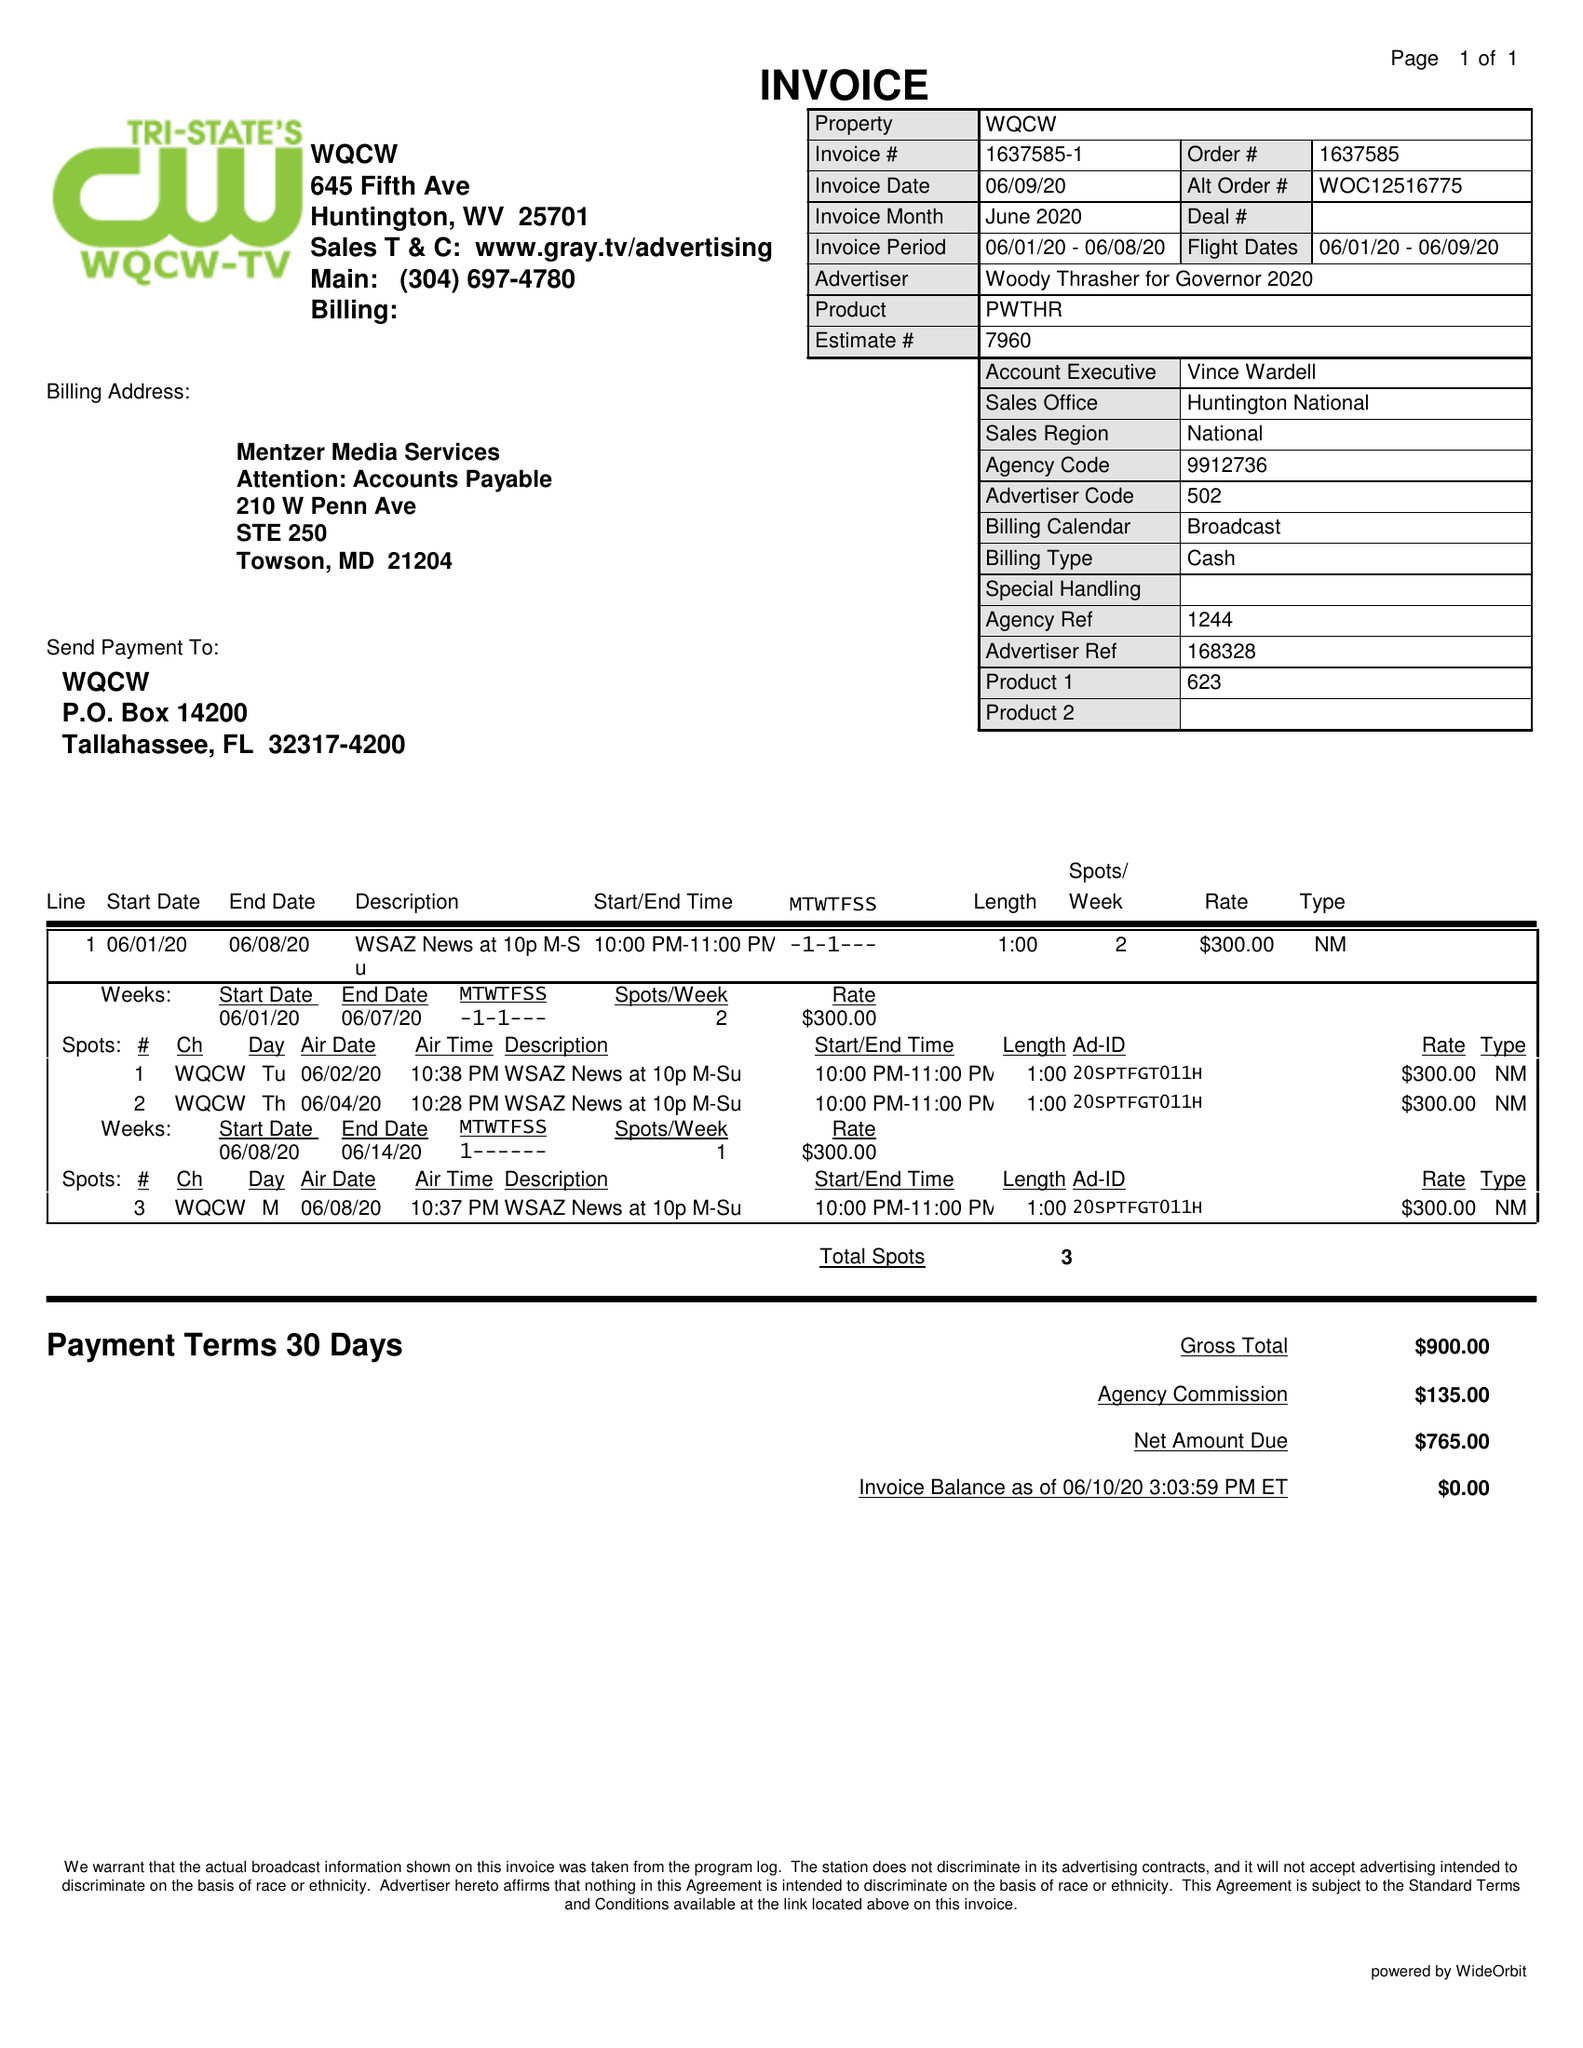What is the value for the contract_num?
Answer the question using a single word or phrase. 1637585 